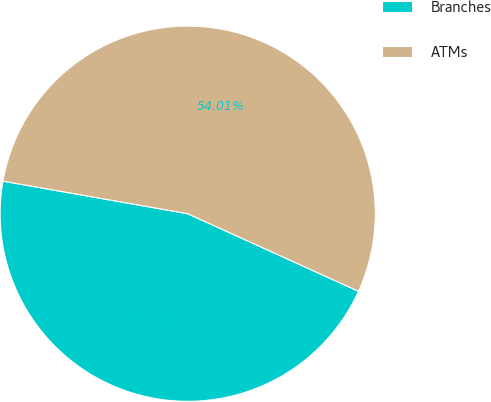Convert chart to OTSL. <chart><loc_0><loc_0><loc_500><loc_500><pie_chart><fcel>Branches<fcel>ATMs<nl><fcel>45.99%<fcel>54.01%<nl></chart> 